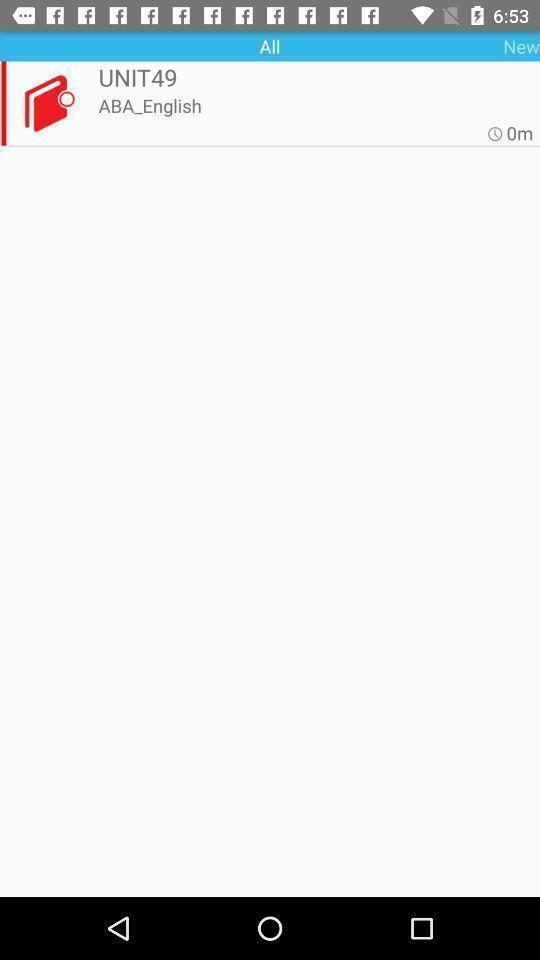Provide a textual representation of this image. Unit page displaying. 